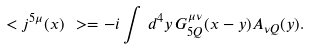Convert formula to latex. <formula><loc_0><loc_0><loc_500><loc_500>\ < j ^ { 5 \mu } ( x ) \ > = - i \int \, d ^ { 4 } y \, G ^ { \mu \nu } _ { 5 Q } ( x - y ) A _ { \nu Q } ( y ) .</formula> 